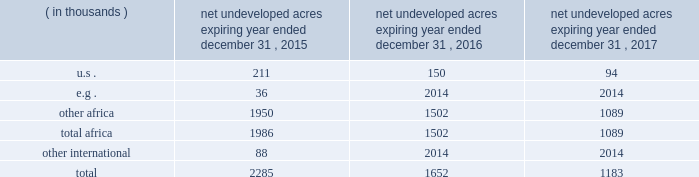In the ordinary course of business , based on our evaluations of certain geologic trends and prospective economics , we have allowed certain lease acreage to expire and may allow additional acreage to expire in the future .
If production is not established or we take no other action to extend the terms of the leases , licenses , or concessions , undeveloped acreage listed in the table below will expire over the next three years .
We plan to continue the terms of many of these licenses and concession areas or retain leases through operational or administrative actions .
Net undeveloped acres expiring year ended december 31 .
Oil sands mining segment we hold a 20 percent non-operated interest in the aosp , an oil sands mining and upgrading joint venture located in alberta , canada .
The joint venture produces bitumen from oil sands deposits in the athabasca region utilizing mining techniques and upgrades the bitumen to synthetic crude oils and vacuum gas oil .
The aosp 2019s mining and extraction assets are located near fort mcmurray , alberta , and include the muskeg river and the jackpine mines .
Gross design capacity of the combined mines is 255000 ( 51000 net to our interest ) barrels of bitumen per day .
The aosp operations use established processes to mine oil sands deposits from an open-pit mine , extract the bitumen and upgrade it into synthetic crude oils .
Ore is mined using traditional truck and shovel mining techniques .
The mined ore passes through primary crushers to reduce the ore chunks in size and is then sent to rotary breakers where the ore chunks are further reduced to smaller particles .
The particles are combined with hot water to create slurry .
The slurry moves through the extraction process where it separates into sand , clay and bitumen-rich froth .
A solvent is added to the bitumen froth to separate out the remaining solids , water and heavy asphaltenes .
The solvent washes the sand and produces clean bitumen that is required for the upgrader to run efficiently .
The process yields a mixture of solvent and bitumen which is then transported from the mine to the scotford upgrader via the approximately 300-mile corridor pipeline .
The aosp's scotford upgrader is located at fort saskatchewan , northeast of edmonton , alberta .
The bitumen is upgraded at scotford using both hydrotreating and hydroconversion processes to remove sulfur and break the heavy bitumen molecules into lighter products .
Blendstocks acquired from outside sources are utilized in the production of our saleable products .
The upgrader produces synthetic crude oils and vacuum gas oil .
The vacuum gas oil is sold to an affiliate of the operator under a long-term contract at market-related prices , and the other products are sold in the marketplace .
As of december 31 , 2014 , we own or have rights to participate in developed and undeveloped leases totaling approximately 163000 gross ( 33000 net ) acres .
The underlying developed leases are held for the duration of the project , with royalties payable to the province of alberta .
Synthetic crude oil sales volumes for 2014 averaged 50 mbbld and net-of-royalty production was 41 mbbld .
In december 2013 , a jackpine mine expansion project received conditional approval from the canadian government .
The project includes additional mining areas , associated processing facilities and infrastructure .
The government conditions relate to wildlife , the environment and aboriginal health issues .
We will evaluate the potential expansion project and government conditions after infrastructure reliability initiatives are completed .
The governments of alberta and canada have agreed to partially fund quest ccs for $ 865 million canadian .
In the third quarter of 2012 , the energy and resources conservation board ( "ercb" ) , alberta's primary energy regulator at that time , conditionally approved the project and the aosp partners approved proceeding to construct and operate quest ccs .
Government funding commenced in 2012 and continued as milestones were achieved during the development , construction and operating phases .
Failure of the aosp to meet certain timing , performance and operating objectives may result in repaying some of the government funding .
Construction and commissioning of quest ccs is expected to be completed by late 2015. .
What is our percentage of our interest in the aosp 2019s mining and extraction assets located near fort mcmurray , including the muskeg river and the jackpine mines? 
Computations: (51000 / 255000)
Answer: 0.2. 